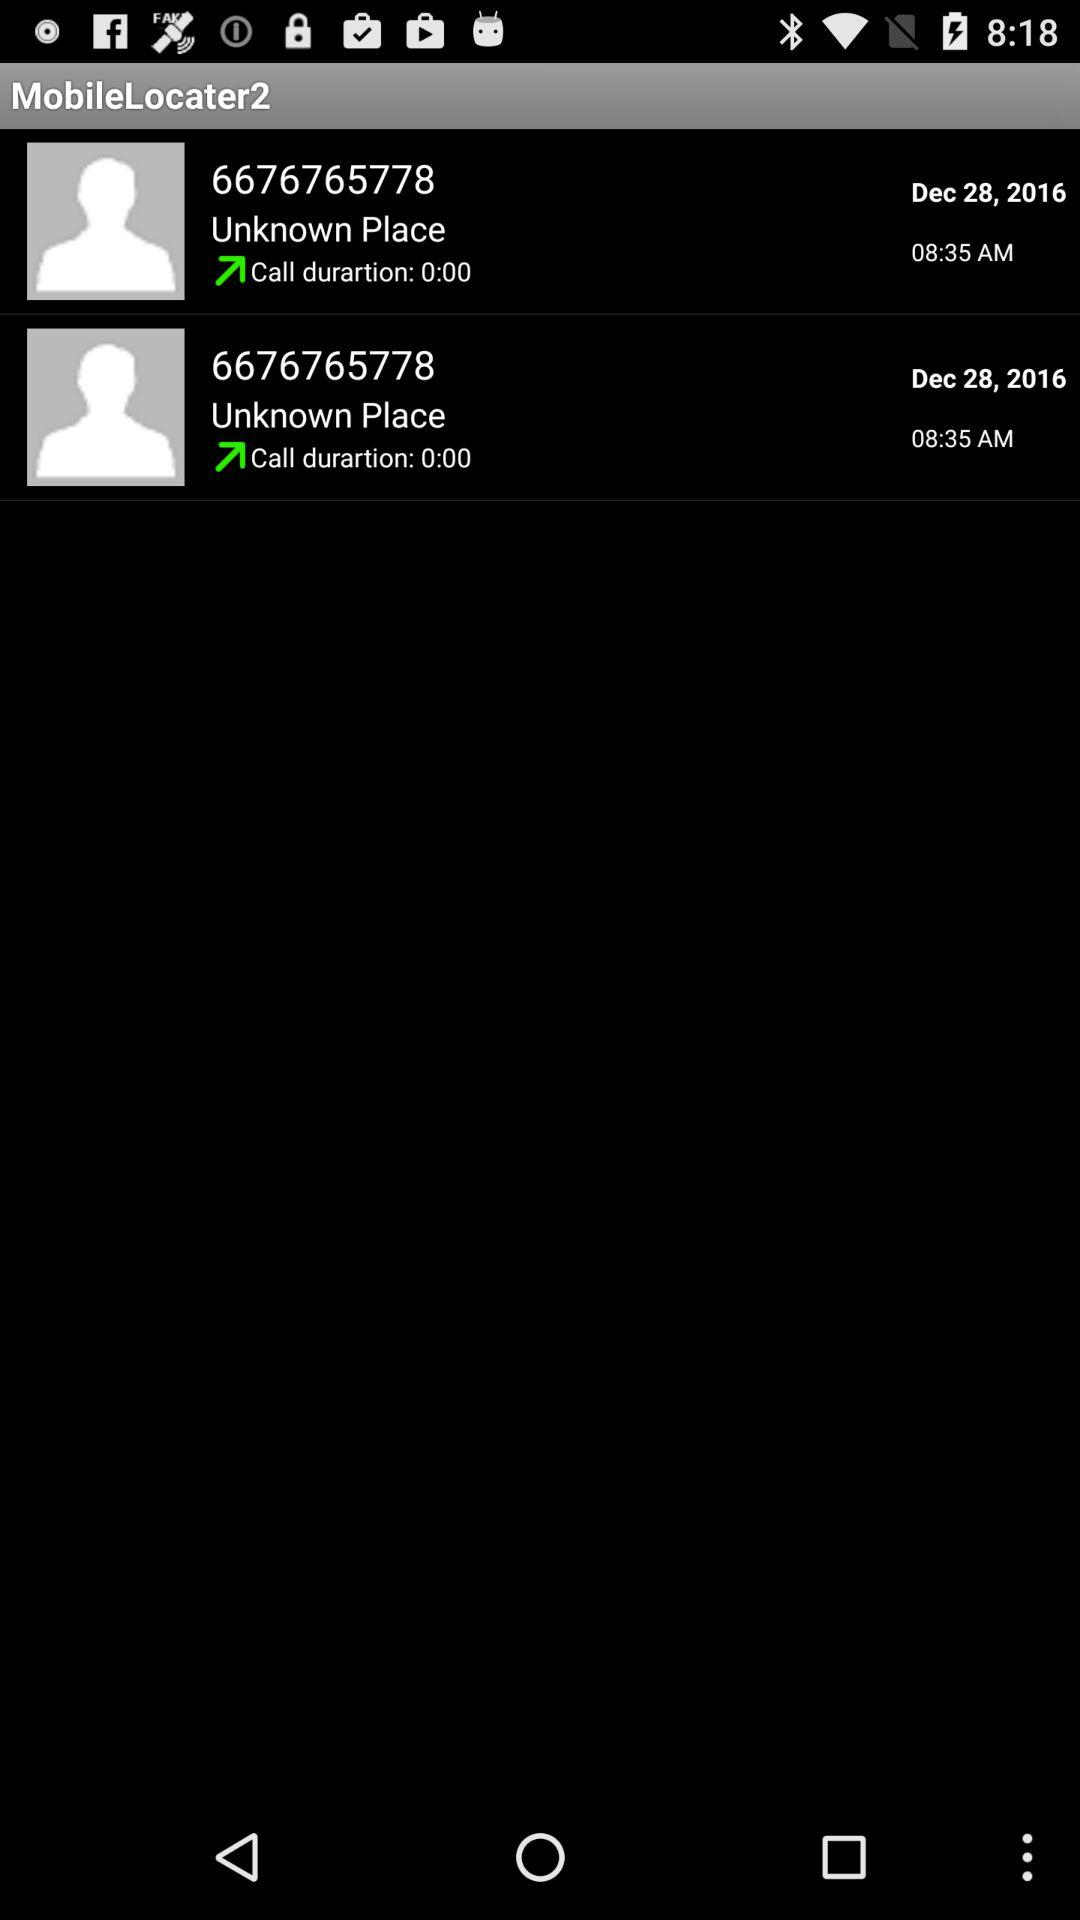What was the date of the calls? The date of the calls was December 28, 2016. 